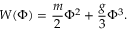<formula> <loc_0><loc_0><loc_500><loc_500>W ( \Phi ) = \frac { m } { 2 } \Phi ^ { 2 } + \frac { g } { 3 } \Phi ^ { 3 } .</formula> 